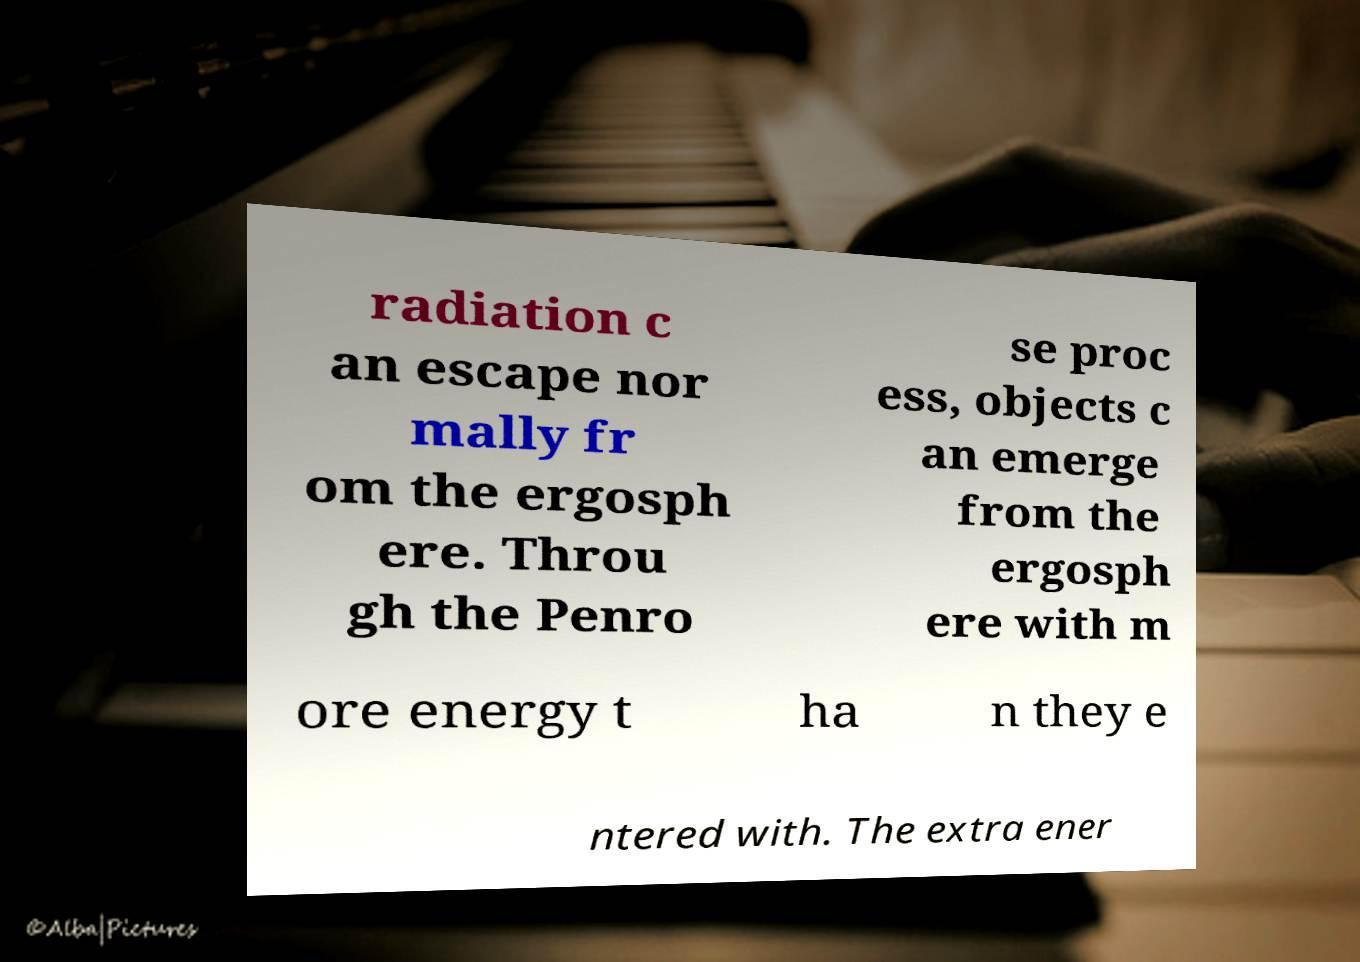What messages or text are displayed in this image? I need them in a readable, typed format. radiation c an escape nor mally fr om the ergosph ere. Throu gh the Penro se proc ess, objects c an emerge from the ergosph ere with m ore energy t ha n they e ntered with. The extra ener 